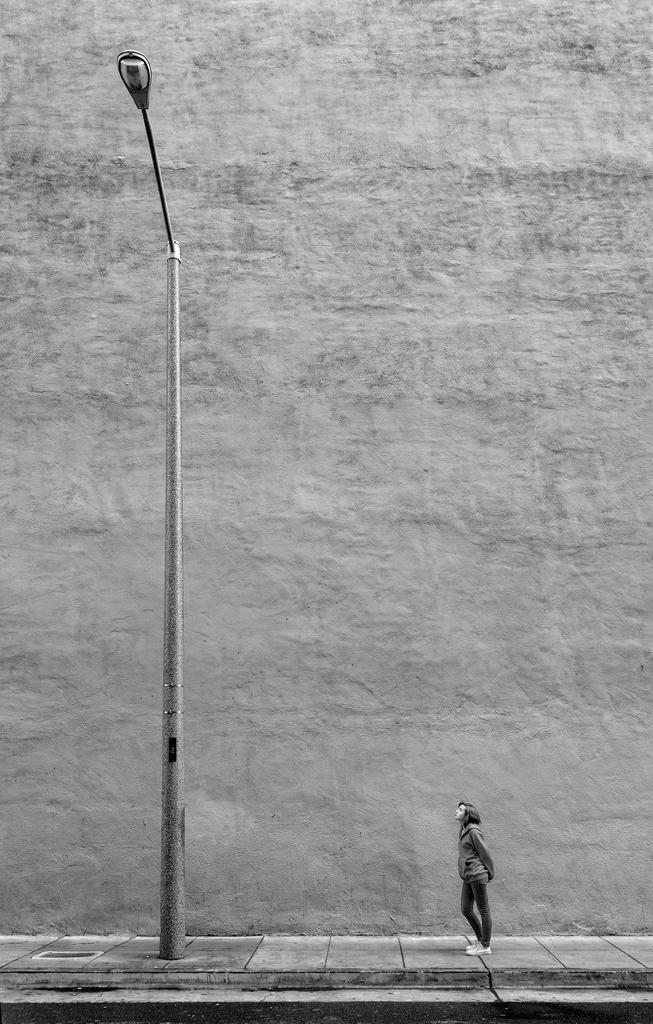What is the main subject in the image? There is a person standing in the image. What object with a pole can be seen in the image? There is a light with a pole in the image. What type of structure is visible in the background? There is a wall in the background of the image. What type of experience does the person have with helping others in the image? There is no information about the person's experience with helping others in the image. 